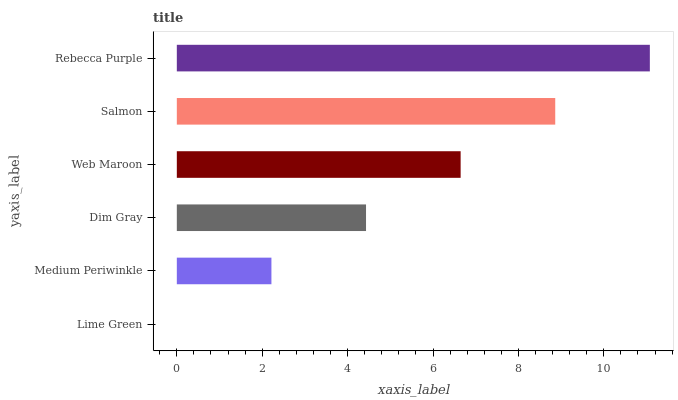Is Lime Green the minimum?
Answer yes or no. Yes. Is Rebecca Purple the maximum?
Answer yes or no. Yes. Is Medium Periwinkle the minimum?
Answer yes or no. No. Is Medium Periwinkle the maximum?
Answer yes or no. No. Is Medium Periwinkle greater than Lime Green?
Answer yes or no. Yes. Is Lime Green less than Medium Periwinkle?
Answer yes or no. Yes. Is Lime Green greater than Medium Periwinkle?
Answer yes or no. No. Is Medium Periwinkle less than Lime Green?
Answer yes or no. No. Is Web Maroon the high median?
Answer yes or no. Yes. Is Dim Gray the low median?
Answer yes or no. Yes. Is Salmon the high median?
Answer yes or no. No. Is Medium Periwinkle the low median?
Answer yes or no. No. 